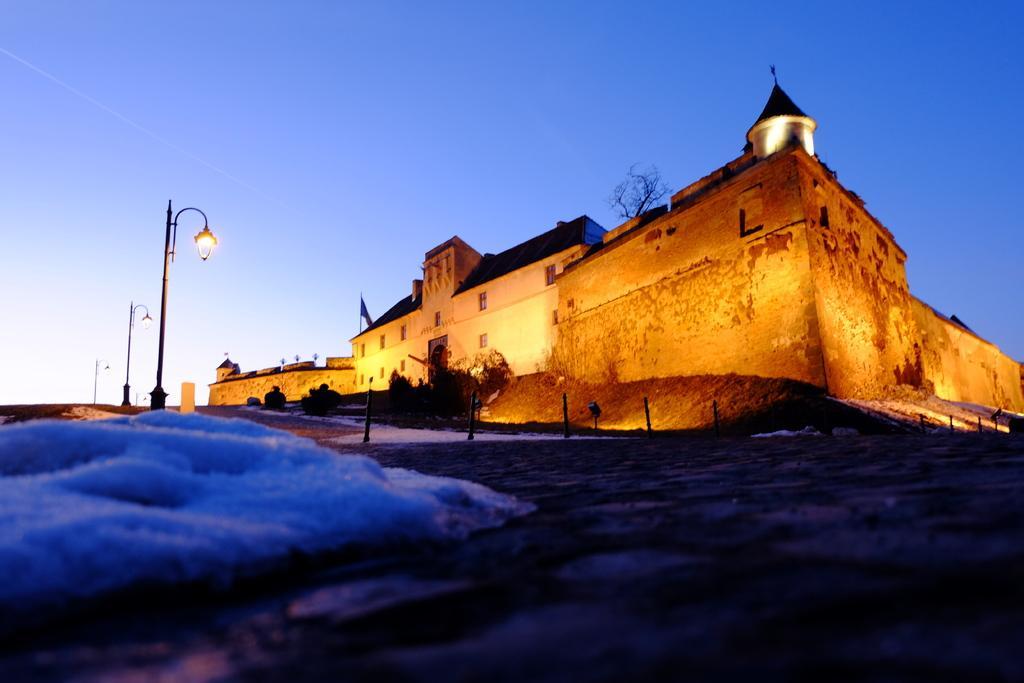Describe this image in one or two sentences. In the foreground of the picture I can see the snow. I can see the building and I can see a flagpole. I can see the decorative lamp poles on the left side. There are clouds in the sky. 